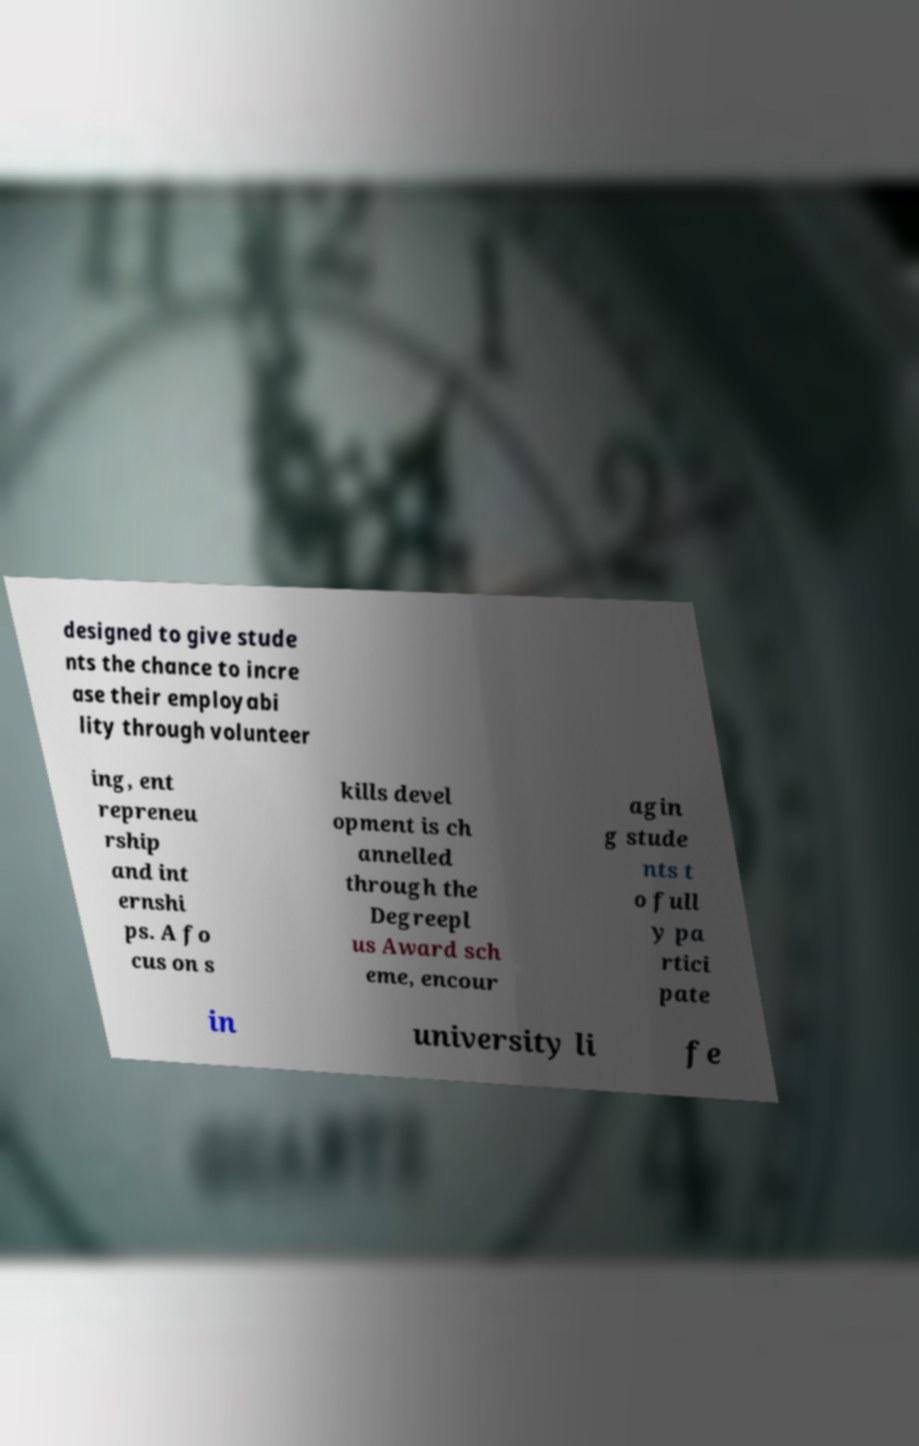Can you accurately transcribe the text from the provided image for me? designed to give stude nts the chance to incre ase their employabi lity through volunteer ing, ent repreneu rship and int ernshi ps. A fo cus on s kills devel opment is ch annelled through the Degreepl us Award sch eme, encour agin g stude nts t o full y pa rtici pate in university li fe 